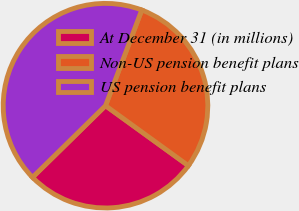<chart> <loc_0><loc_0><loc_500><loc_500><pie_chart><fcel>At December 31 (in millions)<fcel>Non-US pension benefit plans<fcel>US pension benefit plans<nl><fcel>27.67%<fcel>29.21%<fcel>43.12%<nl></chart> 